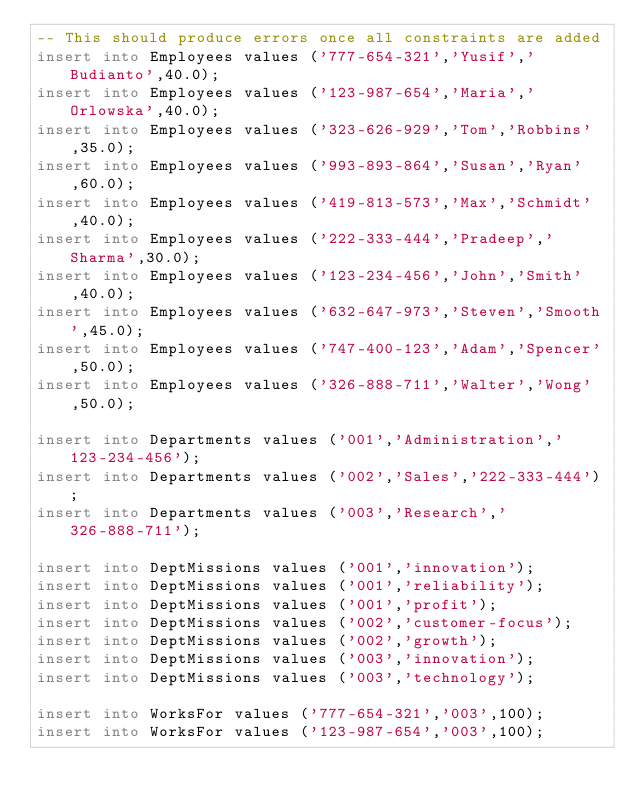<code> <loc_0><loc_0><loc_500><loc_500><_SQL_>-- This should produce errors once all constraints are added
insert into Employees values ('777-654-321','Yusif','Budianto',40.0);
insert into Employees values ('123-987-654','Maria','Orlowska',40.0);
insert into Employees values ('323-626-929','Tom','Robbins',35.0);
insert into Employees values ('993-893-864','Susan','Ryan',60.0);
insert into Employees values ('419-813-573','Max','Schmidt',40.0);
insert into Employees values ('222-333-444','Pradeep','Sharma',30.0);
insert into Employees values ('123-234-456','John','Smith',40.0);
insert into Employees values ('632-647-973','Steven','Smooth',45.0);
insert into Employees values ('747-400-123','Adam','Spencer',50.0);
insert into Employees values ('326-888-711','Walter','Wong',50.0);

insert into Departments values ('001','Administration','123-234-456');
insert into Departments values ('002','Sales','222-333-444');
insert into Departments values ('003','Research','326-888-711');

insert into DeptMissions values ('001','innovation');
insert into DeptMissions values ('001','reliability');
insert into DeptMissions values ('001','profit');
insert into DeptMissions values ('002','customer-focus');
insert into DeptMissions values ('002','growth');
insert into DeptMissions values ('003','innovation');
insert into DeptMissions values ('003','technology');

insert into WorksFor values ('777-654-321','003',100);
insert into WorksFor values ('123-987-654','003',100);</code> 